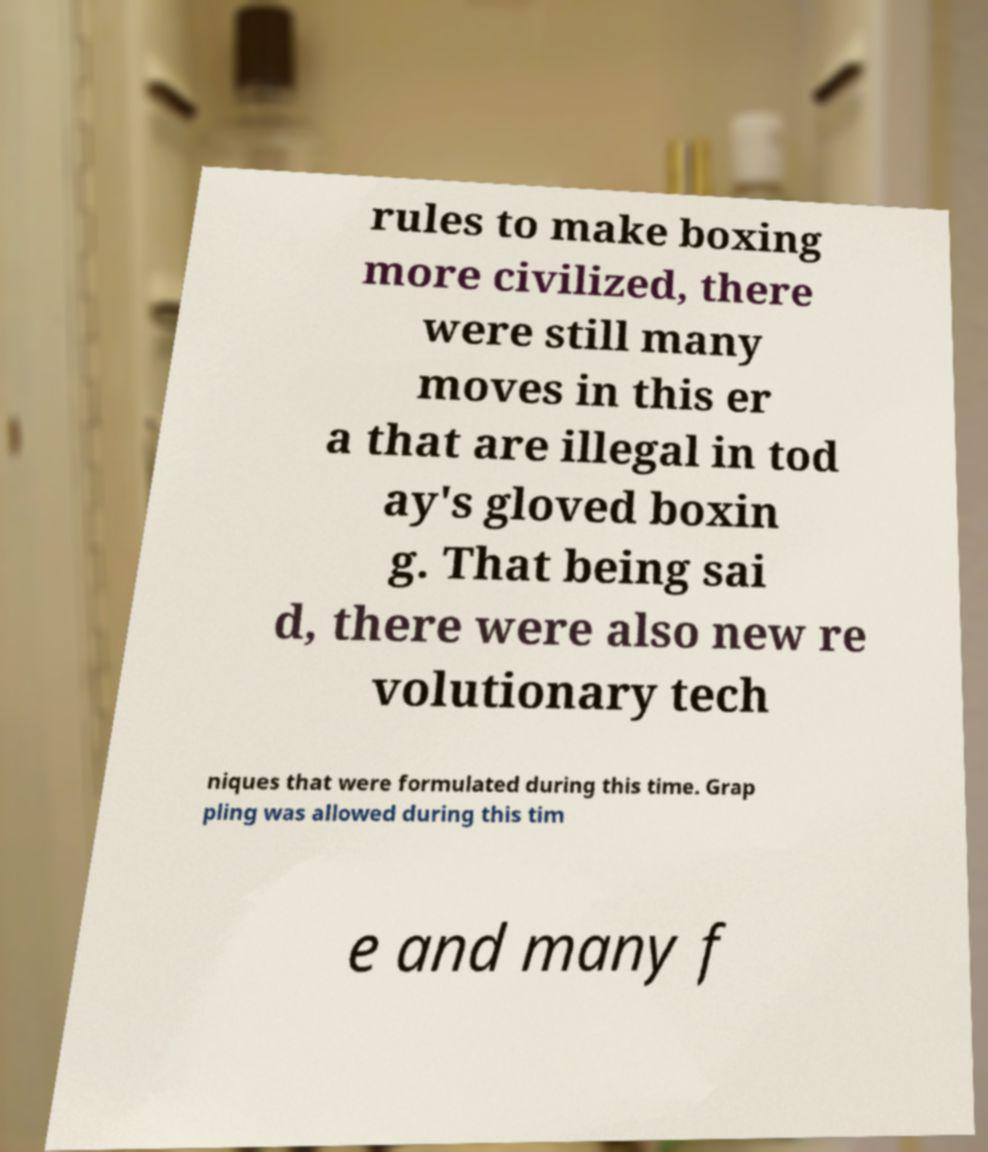What messages or text are displayed in this image? I need them in a readable, typed format. rules to make boxing more civilized, there were still many moves in this er a that are illegal in tod ay's gloved boxin g. That being sai d, there were also new re volutionary tech niques that were formulated during this time. Grap pling was allowed during this tim e and many f 